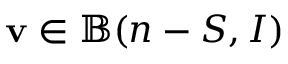<formula> <loc_0><loc_0><loc_500><loc_500>v \in \mathbb { B } ( n - S , I )</formula> 